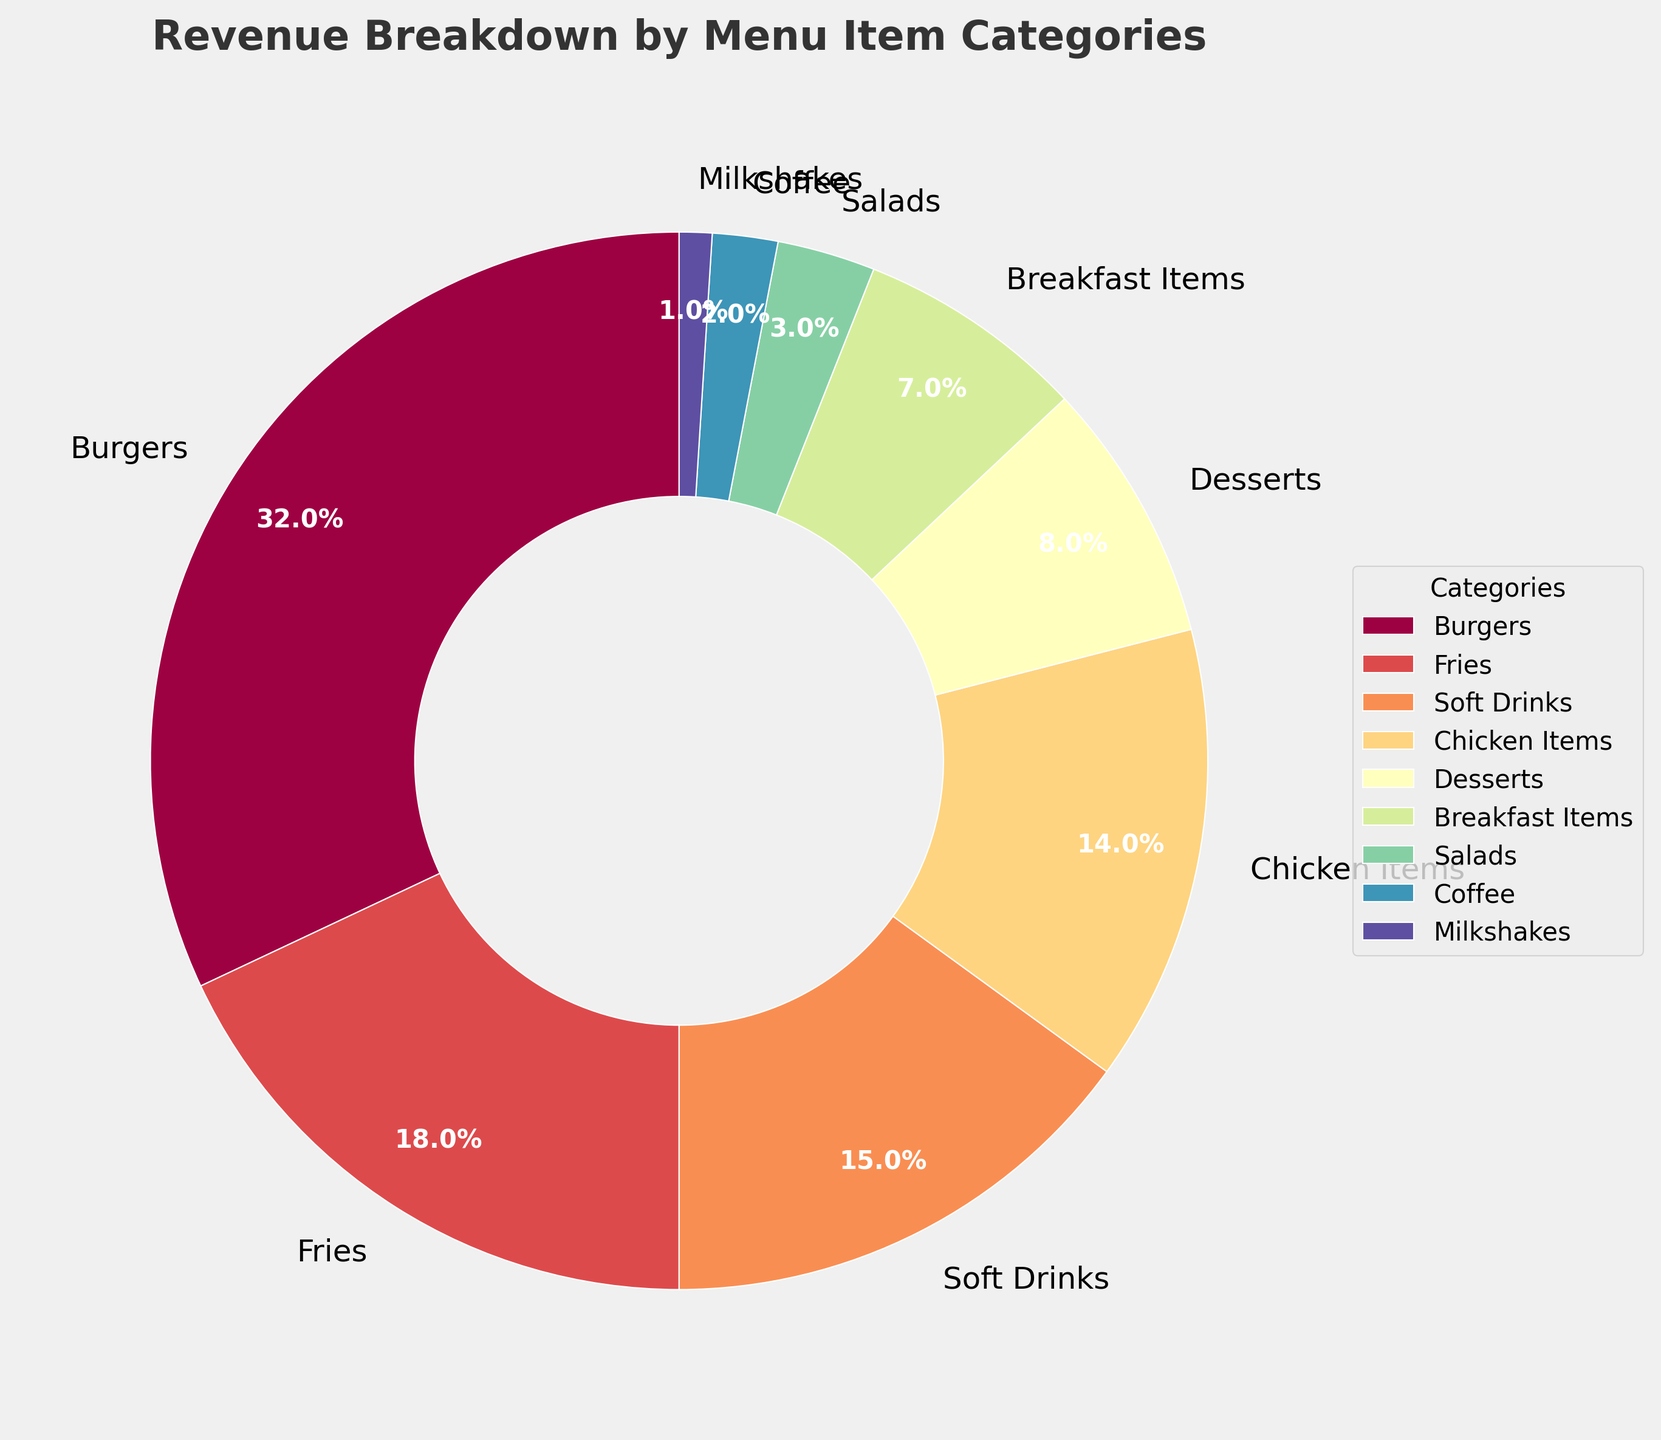Which menu item category generates the highest percentage of revenue? The figure shows a pie chart with various categories labeled with their revenue percentages. Burgers have the highest percentage at 32%.
Answer: Burgers What is the combined revenue percentage of Fries and Soft Drinks? To find the combined percentage, add the revenue percentages of Fries (18%) and Soft Drinks (15%). So, 18 + 15 = 33.
Answer: 33% How much more revenue percentage do Burgers generate compared to Chicken Items? The revenue percentage for Burgers is 32%, and for Chicken Items, it is 14%. The difference is 32 - 14 = 18.
Answer: 18% Which category contributes least to the revenue? The pie chart shows that Milkshakes have the smallest segment with 1%.
Answer: Milkshakes What is the total revenue percentage contributed by Desserts, Breakfast Items, and Salads combined? Sum the percentages of Desserts (8%), Breakfast Items (7%), and Salads (3%). So, 8 + 7 + 3 = 18.
Answer: 18% How does the revenue percentage of Soft Drinks compare to Coffee? The pie chart indicates Soft Drinks have 15% and Coffee has 2%. Since 15 > 2, Soft Drinks generate more revenue than Coffee.
Answer: Soft Drinks generate more What proportion of revenue is generated by items other than Burgers, Fries, and Chicken Items? To find this, subtract the combined revenue of Burgers (32%), Fries (18%), and Chicken Items (14%) from 100%. The combined percentage is 32 + 18 + 14 = 64. Therefore, 100 - 64 = 36.
Answer: 36% Which category generates more revenue, Soft Drinks or Desserts? The chart shows Soft Drinks at 15% and Desserts at 8%. Since 15% is greater than 8%, Soft Drinks generate more revenue.
Answer: Soft Drinks What is the combined percentage for all categories generating less than 10% revenue each? The categories generating less than 10% are Desserts (8%), Breakfast Items (7%), Salads (3%), Coffee (2%), and Milkshakes (1%). Sum these percentages: 8 + 7 + 3 + 2 + 1 = 21.
Answer: 21% Is the revenue percentage from Burgers higher than the combined revenue percentage of Chicken Items and Soft Drinks? Burgers generate 32%. The combined revenue for Chicken Items (14%) and Soft Drinks (15%) is 14 + 15 = 29%. Since 32% is greater than 29%, Burgers generate more revenue.
Answer: Yes 